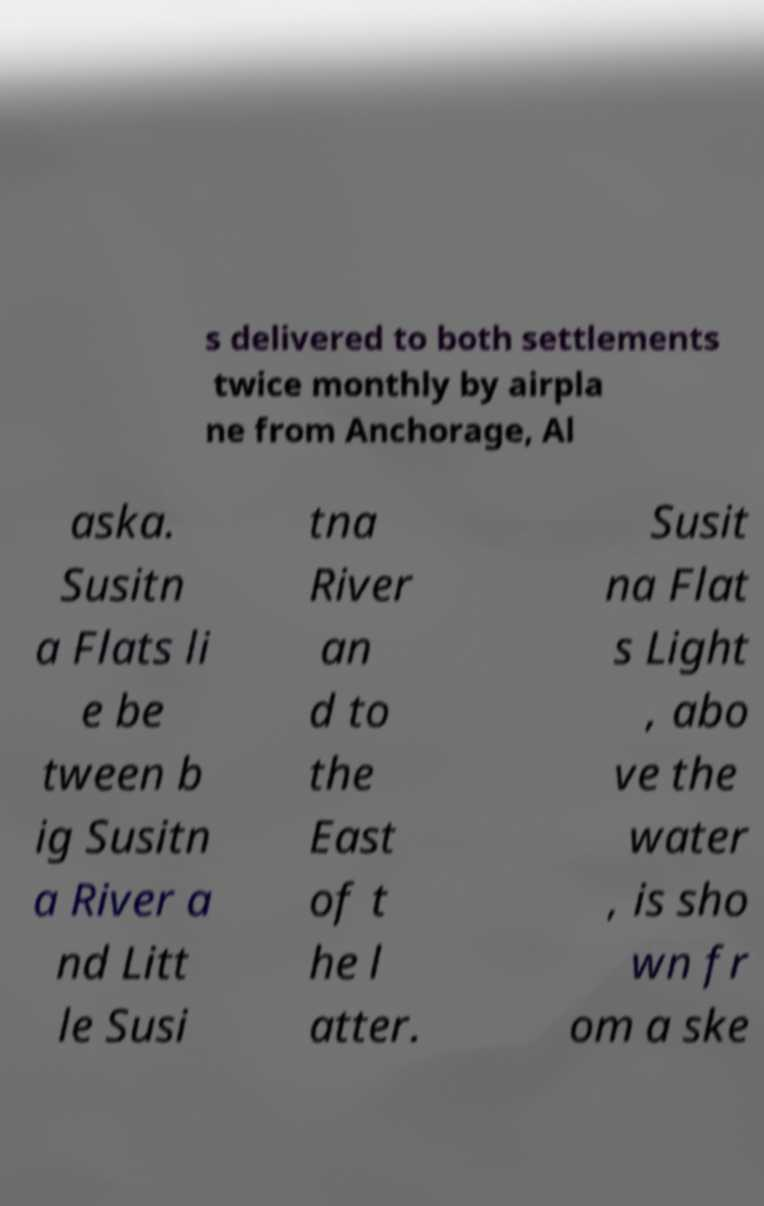Can you read and provide the text displayed in the image?This photo seems to have some interesting text. Can you extract and type it out for me? s delivered to both settlements twice monthly by airpla ne from Anchorage, Al aska. Susitn a Flats li e be tween b ig Susitn a River a nd Litt le Susi tna River an d to the East of t he l atter. Susit na Flat s Light , abo ve the water , is sho wn fr om a ske 